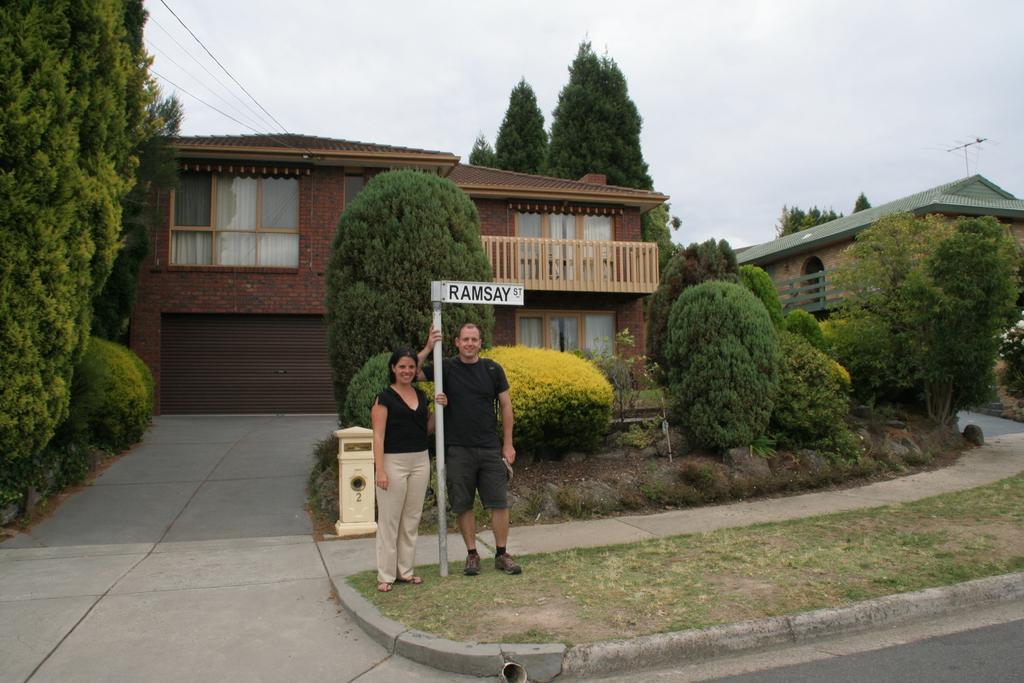In one or two sentences, can you explain what this image depicts? In the foreground of the picture there are road, pavement, pole, board, dustbin, grass, woman and a man. In the center of the picture there are trees, plants, houses, cables and current pole. At the top it is sky, sky is cloudy. 